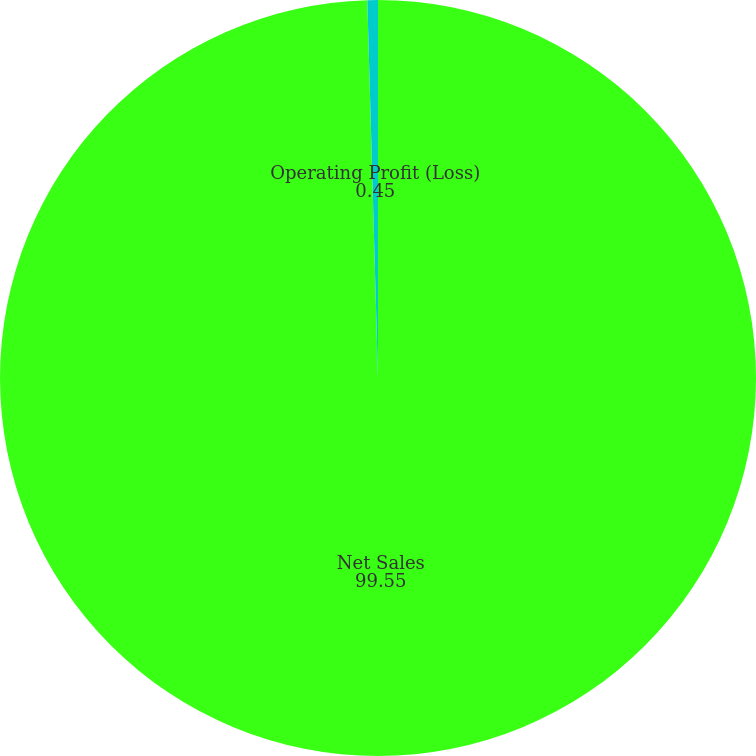<chart> <loc_0><loc_0><loc_500><loc_500><pie_chart><fcel>Net Sales<fcel>Operating Profit (Loss)<nl><fcel>99.55%<fcel>0.45%<nl></chart> 